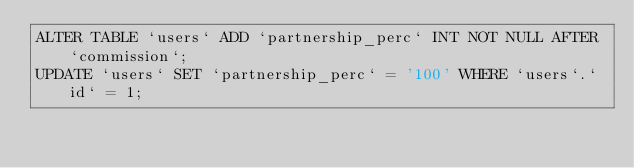Convert code to text. <code><loc_0><loc_0><loc_500><loc_500><_SQL_>ALTER TABLE `users` ADD `partnership_perc` INT NOT NULL AFTER `commission`;
UPDATE `users` SET `partnership_perc` = '100' WHERE `users`.`id` = 1;</code> 